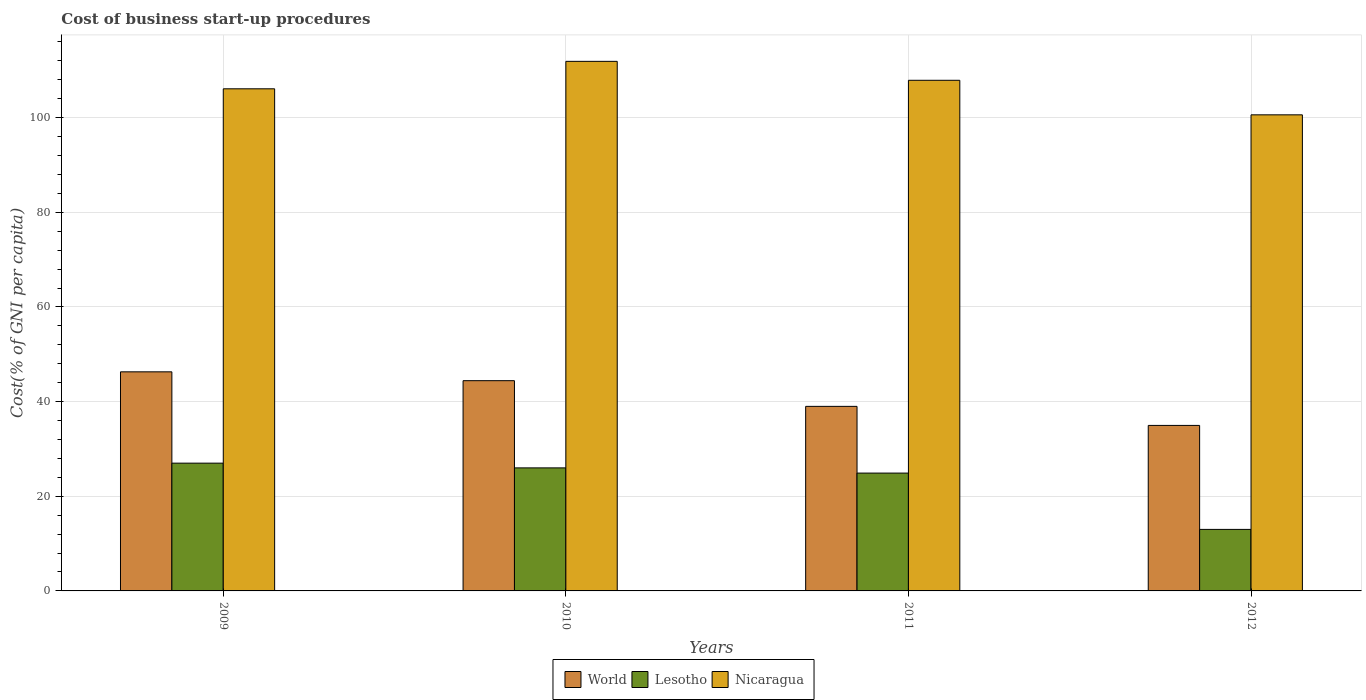How many different coloured bars are there?
Your answer should be very brief. 3. How many groups of bars are there?
Make the answer very short. 4. Are the number of bars per tick equal to the number of legend labels?
Give a very brief answer. Yes. Are the number of bars on each tick of the X-axis equal?
Give a very brief answer. Yes. How many bars are there on the 2nd tick from the right?
Make the answer very short. 3. In how many cases, is the number of bars for a given year not equal to the number of legend labels?
Provide a short and direct response. 0. What is the cost of business start-up procedures in Lesotho in 2012?
Your answer should be very brief. 13. Across all years, what is the maximum cost of business start-up procedures in Nicaragua?
Offer a terse response. 111.9. Across all years, what is the minimum cost of business start-up procedures in World?
Keep it short and to the point. 34.97. What is the total cost of business start-up procedures in Nicaragua in the graph?
Make the answer very short. 426.5. What is the difference between the cost of business start-up procedures in Lesotho in 2011 and the cost of business start-up procedures in World in 2010?
Ensure brevity in your answer.  -19.52. What is the average cost of business start-up procedures in World per year?
Provide a short and direct response. 41.17. In the year 2011, what is the difference between the cost of business start-up procedures in World and cost of business start-up procedures in Lesotho?
Your response must be concise. 14.1. What is the ratio of the cost of business start-up procedures in Lesotho in 2009 to that in 2010?
Ensure brevity in your answer.  1.04. Is the cost of business start-up procedures in Lesotho in 2010 less than that in 2012?
Keep it short and to the point. No. What is the difference between the highest and the lowest cost of business start-up procedures in World?
Make the answer very short. 11.32. What does the 3rd bar from the left in 2012 represents?
Your answer should be compact. Nicaragua. What does the 2nd bar from the right in 2011 represents?
Keep it short and to the point. Lesotho. Is it the case that in every year, the sum of the cost of business start-up procedures in World and cost of business start-up procedures in Nicaragua is greater than the cost of business start-up procedures in Lesotho?
Offer a very short reply. Yes. Are all the bars in the graph horizontal?
Provide a succinct answer. No. How many years are there in the graph?
Offer a terse response. 4. Does the graph contain grids?
Keep it short and to the point. Yes. Where does the legend appear in the graph?
Offer a terse response. Bottom center. How many legend labels are there?
Provide a short and direct response. 3. What is the title of the graph?
Ensure brevity in your answer.  Cost of business start-up procedures. Does "Brunei Darussalam" appear as one of the legend labels in the graph?
Give a very brief answer. No. What is the label or title of the X-axis?
Make the answer very short. Years. What is the label or title of the Y-axis?
Provide a succinct answer. Cost(% of GNI per capita). What is the Cost(% of GNI per capita) of World in 2009?
Provide a short and direct response. 46.29. What is the Cost(% of GNI per capita) in Lesotho in 2009?
Your answer should be compact. 27. What is the Cost(% of GNI per capita) in Nicaragua in 2009?
Your answer should be compact. 106.1. What is the Cost(% of GNI per capita) of World in 2010?
Ensure brevity in your answer.  44.42. What is the Cost(% of GNI per capita) in Lesotho in 2010?
Offer a terse response. 26. What is the Cost(% of GNI per capita) in Nicaragua in 2010?
Provide a succinct answer. 111.9. What is the Cost(% of GNI per capita) of World in 2011?
Your response must be concise. 39. What is the Cost(% of GNI per capita) in Lesotho in 2011?
Provide a short and direct response. 24.9. What is the Cost(% of GNI per capita) in Nicaragua in 2011?
Ensure brevity in your answer.  107.9. What is the Cost(% of GNI per capita) in World in 2012?
Your response must be concise. 34.97. What is the Cost(% of GNI per capita) of Lesotho in 2012?
Your answer should be compact. 13. What is the Cost(% of GNI per capita) in Nicaragua in 2012?
Provide a short and direct response. 100.6. Across all years, what is the maximum Cost(% of GNI per capita) of World?
Your answer should be very brief. 46.29. Across all years, what is the maximum Cost(% of GNI per capita) in Lesotho?
Your answer should be compact. 27. Across all years, what is the maximum Cost(% of GNI per capita) in Nicaragua?
Your answer should be compact. 111.9. Across all years, what is the minimum Cost(% of GNI per capita) of World?
Offer a terse response. 34.97. Across all years, what is the minimum Cost(% of GNI per capita) in Lesotho?
Provide a short and direct response. 13. Across all years, what is the minimum Cost(% of GNI per capita) in Nicaragua?
Keep it short and to the point. 100.6. What is the total Cost(% of GNI per capita) in World in the graph?
Your answer should be compact. 164.69. What is the total Cost(% of GNI per capita) of Lesotho in the graph?
Offer a very short reply. 90.9. What is the total Cost(% of GNI per capita) in Nicaragua in the graph?
Give a very brief answer. 426.5. What is the difference between the Cost(% of GNI per capita) in World in 2009 and that in 2010?
Your answer should be very brief. 1.87. What is the difference between the Cost(% of GNI per capita) in Nicaragua in 2009 and that in 2010?
Offer a very short reply. -5.8. What is the difference between the Cost(% of GNI per capita) of World in 2009 and that in 2011?
Give a very brief answer. 7.3. What is the difference between the Cost(% of GNI per capita) in Lesotho in 2009 and that in 2011?
Offer a terse response. 2.1. What is the difference between the Cost(% of GNI per capita) of Nicaragua in 2009 and that in 2011?
Your answer should be very brief. -1.8. What is the difference between the Cost(% of GNI per capita) in World in 2009 and that in 2012?
Provide a short and direct response. 11.32. What is the difference between the Cost(% of GNI per capita) in Lesotho in 2009 and that in 2012?
Give a very brief answer. 14. What is the difference between the Cost(% of GNI per capita) in World in 2010 and that in 2011?
Keep it short and to the point. 5.43. What is the difference between the Cost(% of GNI per capita) of Lesotho in 2010 and that in 2011?
Keep it short and to the point. 1.1. What is the difference between the Cost(% of GNI per capita) of World in 2010 and that in 2012?
Your answer should be compact. 9.45. What is the difference between the Cost(% of GNI per capita) of Lesotho in 2010 and that in 2012?
Ensure brevity in your answer.  13. What is the difference between the Cost(% of GNI per capita) of World in 2011 and that in 2012?
Provide a succinct answer. 4.03. What is the difference between the Cost(% of GNI per capita) of Nicaragua in 2011 and that in 2012?
Your response must be concise. 7.3. What is the difference between the Cost(% of GNI per capita) in World in 2009 and the Cost(% of GNI per capita) in Lesotho in 2010?
Give a very brief answer. 20.29. What is the difference between the Cost(% of GNI per capita) in World in 2009 and the Cost(% of GNI per capita) in Nicaragua in 2010?
Offer a very short reply. -65.61. What is the difference between the Cost(% of GNI per capita) in Lesotho in 2009 and the Cost(% of GNI per capita) in Nicaragua in 2010?
Provide a short and direct response. -84.9. What is the difference between the Cost(% of GNI per capita) of World in 2009 and the Cost(% of GNI per capita) of Lesotho in 2011?
Your answer should be compact. 21.39. What is the difference between the Cost(% of GNI per capita) of World in 2009 and the Cost(% of GNI per capita) of Nicaragua in 2011?
Your answer should be very brief. -61.61. What is the difference between the Cost(% of GNI per capita) of Lesotho in 2009 and the Cost(% of GNI per capita) of Nicaragua in 2011?
Ensure brevity in your answer.  -80.9. What is the difference between the Cost(% of GNI per capita) of World in 2009 and the Cost(% of GNI per capita) of Lesotho in 2012?
Your response must be concise. 33.29. What is the difference between the Cost(% of GNI per capita) of World in 2009 and the Cost(% of GNI per capita) of Nicaragua in 2012?
Give a very brief answer. -54.31. What is the difference between the Cost(% of GNI per capita) of Lesotho in 2009 and the Cost(% of GNI per capita) of Nicaragua in 2012?
Provide a short and direct response. -73.6. What is the difference between the Cost(% of GNI per capita) in World in 2010 and the Cost(% of GNI per capita) in Lesotho in 2011?
Keep it short and to the point. 19.52. What is the difference between the Cost(% of GNI per capita) of World in 2010 and the Cost(% of GNI per capita) of Nicaragua in 2011?
Keep it short and to the point. -63.48. What is the difference between the Cost(% of GNI per capita) in Lesotho in 2010 and the Cost(% of GNI per capita) in Nicaragua in 2011?
Your response must be concise. -81.9. What is the difference between the Cost(% of GNI per capita) of World in 2010 and the Cost(% of GNI per capita) of Lesotho in 2012?
Your answer should be compact. 31.42. What is the difference between the Cost(% of GNI per capita) of World in 2010 and the Cost(% of GNI per capita) of Nicaragua in 2012?
Provide a short and direct response. -56.18. What is the difference between the Cost(% of GNI per capita) of Lesotho in 2010 and the Cost(% of GNI per capita) of Nicaragua in 2012?
Ensure brevity in your answer.  -74.6. What is the difference between the Cost(% of GNI per capita) of World in 2011 and the Cost(% of GNI per capita) of Lesotho in 2012?
Provide a short and direct response. 26. What is the difference between the Cost(% of GNI per capita) of World in 2011 and the Cost(% of GNI per capita) of Nicaragua in 2012?
Offer a terse response. -61.6. What is the difference between the Cost(% of GNI per capita) of Lesotho in 2011 and the Cost(% of GNI per capita) of Nicaragua in 2012?
Make the answer very short. -75.7. What is the average Cost(% of GNI per capita) of World per year?
Your response must be concise. 41.17. What is the average Cost(% of GNI per capita) in Lesotho per year?
Your answer should be compact. 22.73. What is the average Cost(% of GNI per capita) in Nicaragua per year?
Make the answer very short. 106.62. In the year 2009, what is the difference between the Cost(% of GNI per capita) of World and Cost(% of GNI per capita) of Lesotho?
Make the answer very short. 19.29. In the year 2009, what is the difference between the Cost(% of GNI per capita) of World and Cost(% of GNI per capita) of Nicaragua?
Provide a short and direct response. -59.81. In the year 2009, what is the difference between the Cost(% of GNI per capita) in Lesotho and Cost(% of GNI per capita) in Nicaragua?
Keep it short and to the point. -79.1. In the year 2010, what is the difference between the Cost(% of GNI per capita) in World and Cost(% of GNI per capita) in Lesotho?
Make the answer very short. 18.42. In the year 2010, what is the difference between the Cost(% of GNI per capita) of World and Cost(% of GNI per capita) of Nicaragua?
Your answer should be compact. -67.48. In the year 2010, what is the difference between the Cost(% of GNI per capita) of Lesotho and Cost(% of GNI per capita) of Nicaragua?
Give a very brief answer. -85.9. In the year 2011, what is the difference between the Cost(% of GNI per capita) in World and Cost(% of GNI per capita) in Lesotho?
Keep it short and to the point. 14.1. In the year 2011, what is the difference between the Cost(% of GNI per capita) of World and Cost(% of GNI per capita) of Nicaragua?
Offer a very short reply. -68.9. In the year 2011, what is the difference between the Cost(% of GNI per capita) in Lesotho and Cost(% of GNI per capita) in Nicaragua?
Make the answer very short. -83. In the year 2012, what is the difference between the Cost(% of GNI per capita) of World and Cost(% of GNI per capita) of Lesotho?
Keep it short and to the point. 21.97. In the year 2012, what is the difference between the Cost(% of GNI per capita) of World and Cost(% of GNI per capita) of Nicaragua?
Keep it short and to the point. -65.63. In the year 2012, what is the difference between the Cost(% of GNI per capita) of Lesotho and Cost(% of GNI per capita) of Nicaragua?
Make the answer very short. -87.6. What is the ratio of the Cost(% of GNI per capita) in World in 2009 to that in 2010?
Offer a terse response. 1.04. What is the ratio of the Cost(% of GNI per capita) of Lesotho in 2009 to that in 2010?
Offer a very short reply. 1.04. What is the ratio of the Cost(% of GNI per capita) of Nicaragua in 2009 to that in 2010?
Your answer should be very brief. 0.95. What is the ratio of the Cost(% of GNI per capita) of World in 2009 to that in 2011?
Provide a short and direct response. 1.19. What is the ratio of the Cost(% of GNI per capita) of Lesotho in 2009 to that in 2011?
Keep it short and to the point. 1.08. What is the ratio of the Cost(% of GNI per capita) in Nicaragua in 2009 to that in 2011?
Keep it short and to the point. 0.98. What is the ratio of the Cost(% of GNI per capita) of World in 2009 to that in 2012?
Offer a terse response. 1.32. What is the ratio of the Cost(% of GNI per capita) in Lesotho in 2009 to that in 2012?
Give a very brief answer. 2.08. What is the ratio of the Cost(% of GNI per capita) in Nicaragua in 2009 to that in 2012?
Offer a terse response. 1.05. What is the ratio of the Cost(% of GNI per capita) of World in 2010 to that in 2011?
Offer a very short reply. 1.14. What is the ratio of the Cost(% of GNI per capita) of Lesotho in 2010 to that in 2011?
Make the answer very short. 1.04. What is the ratio of the Cost(% of GNI per capita) in Nicaragua in 2010 to that in 2011?
Give a very brief answer. 1.04. What is the ratio of the Cost(% of GNI per capita) of World in 2010 to that in 2012?
Your answer should be compact. 1.27. What is the ratio of the Cost(% of GNI per capita) of Lesotho in 2010 to that in 2012?
Make the answer very short. 2. What is the ratio of the Cost(% of GNI per capita) of Nicaragua in 2010 to that in 2012?
Your answer should be compact. 1.11. What is the ratio of the Cost(% of GNI per capita) in World in 2011 to that in 2012?
Provide a succinct answer. 1.12. What is the ratio of the Cost(% of GNI per capita) in Lesotho in 2011 to that in 2012?
Offer a terse response. 1.92. What is the ratio of the Cost(% of GNI per capita) in Nicaragua in 2011 to that in 2012?
Your response must be concise. 1.07. What is the difference between the highest and the second highest Cost(% of GNI per capita) in World?
Your answer should be very brief. 1.87. What is the difference between the highest and the second highest Cost(% of GNI per capita) of Lesotho?
Provide a short and direct response. 1. What is the difference between the highest and the second highest Cost(% of GNI per capita) of Nicaragua?
Keep it short and to the point. 4. What is the difference between the highest and the lowest Cost(% of GNI per capita) in World?
Your answer should be compact. 11.32. 